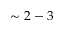Convert formula to latex. <formula><loc_0><loc_0><loc_500><loc_500>\sim 2 - 3</formula> 